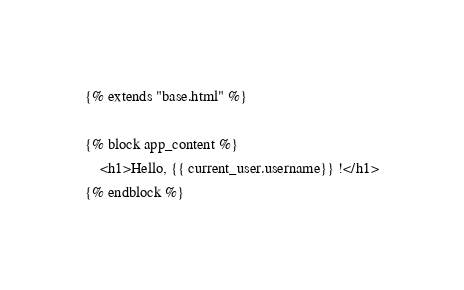Convert code to text. <code><loc_0><loc_0><loc_500><loc_500><_HTML_>{% extends "base.html" %}

{% block app_content %}
    <h1>Hello, {{ current_user.username}} !</h1>
{% endblock %}
</code> 